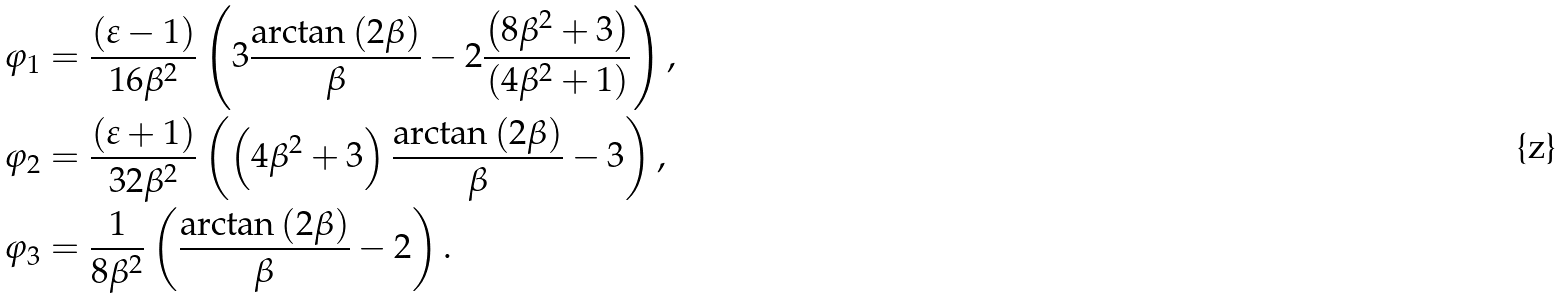<formula> <loc_0><loc_0><loc_500><loc_500>\varphi _ { 1 } & = \frac { \left ( \varepsilon - 1 \right ) } { 1 6 \beta ^ { 2 } } \left ( 3 \frac { \arctan \left ( 2 \beta \right ) } { \beta } - 2 \frac { \left ( 8 \beta ^ { 2 } + 3 \right ) } { \left ( 4 \beta ^ { 2 } + 1 \right ) } \right ) , \\ \varphi _ { 2 } & = \frac { \left ( \varepsilon + 1 \right ) } { 3 2 \beta ^ { 2 } } \left ( \left ( 4 \beta ^ { 2 } + 3 \right ) \frac { \arctan \left ( 2 \beta \right ) } { \beta } - 3 \right ) , \\ \varphi _ { 3 } & = \frac { 1 } { 8 \beta ^ { 2 } } \left ( \frac { \arctan \left ( 2 \beta \right ) } { \beta } - 2 \right ) .</formula> 